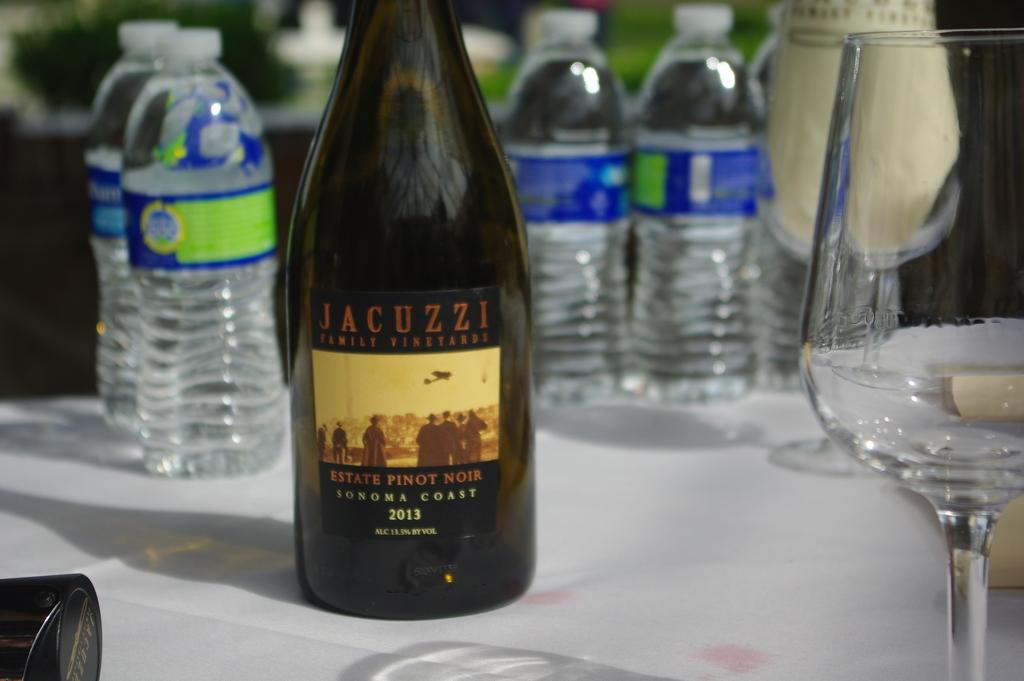Provide a one-sentence caption for the provided image. A bottle of Jacuzzi Pinot Noir in front of water bottles. 